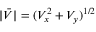<formula> <loc_0><loc_0><loc_500><loc_500>| \bar { V } | = ( V _ { x } ^ { 2 } + V _ { y } ) ^ { 1 / 2 }</formula> 